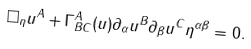Convert formula to latex. <formula><loc_0><loc_0><loc_500><loc_500>\square _ { \eta } u ^ { A } + \Gamma _ { B C } ^ { A } ( u ) \partial _ { \alpha } u ^ { B } \partial _ { \beta } u ^ { C } \eta ^ { \alpha \beta } = 0 .</formula> 